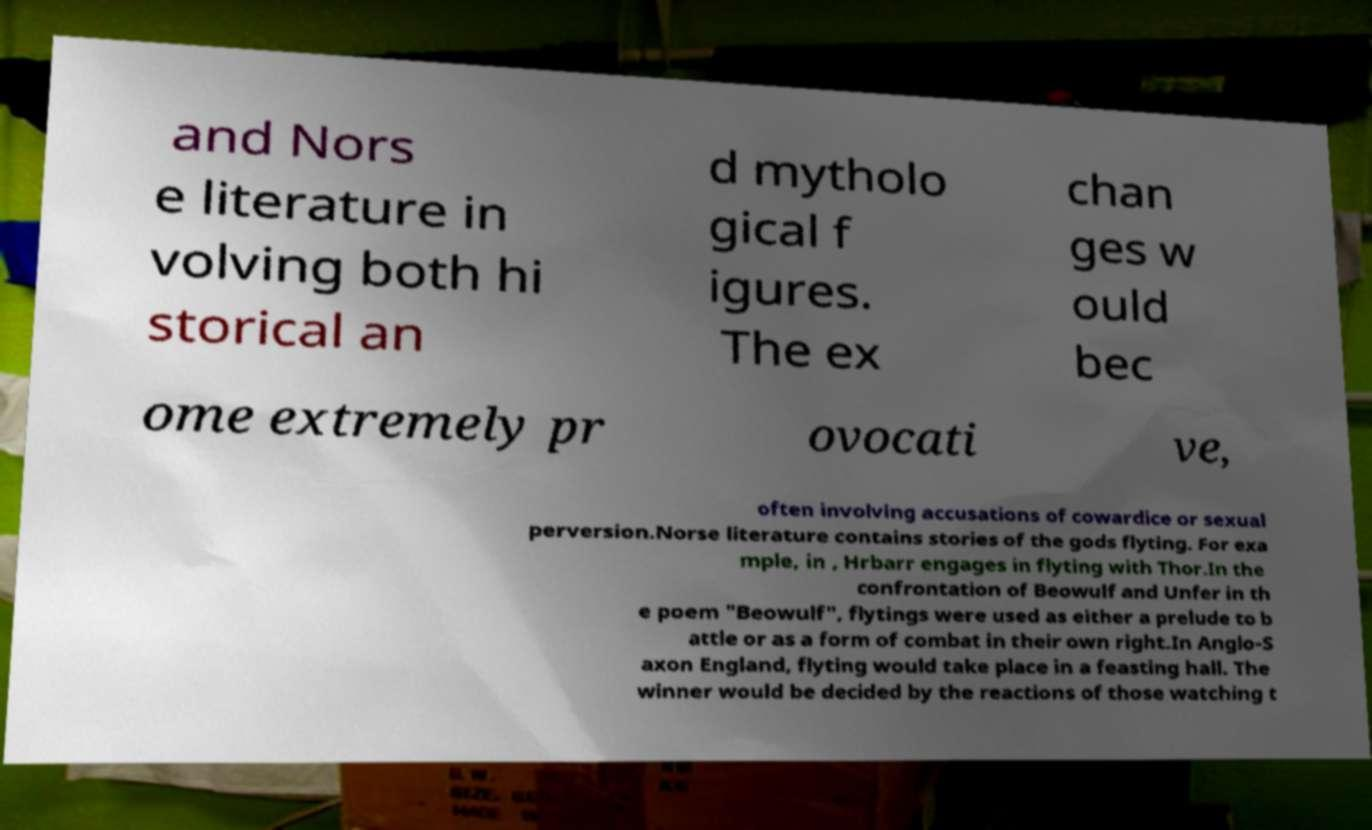I need the written content from this picture converted into text. Can you do that? and Nors e literature in volving both hi storical an d mytholo gical f igures. The ex chan ges w ould bec ome extremely pr ovocati ve, often involving accusations of cowardice or sexual perversion.Norse literature contains stories of the gods flyting. For exa mple, in , Hrbarr engages in flyting with Thor.In the confrontation of Beowulf and Unfer in th e poem "Beowulf", flytings were used as either a prelude to b attle or as a form of combat in their own right.In Anglo-S axon England, flyting would take place in a feasting hall. The winner would be decided by the reactions of those watching t 